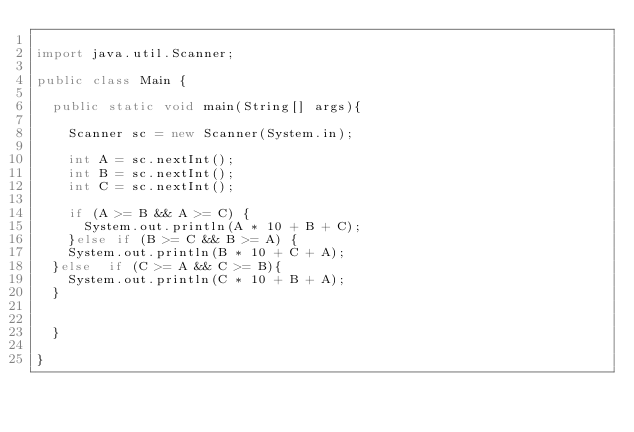<code> <loc_0><loc_0><loc_500><loc_500><_Java_>
import java.util.Scanner;

public class Main {

  public static void main(String[] args){

    Scanner sc = new Scanner(System.in);

    int A = sc.nextInt();
    int B = sc.nextInt();
    int C = sc.nextInt();

    if (A >= B && A >= C) {
      System.out.println(A * 10 + B + C);
    }else if (B >= C && B >= A) {
    System.out.println(B * 10 + C + A);
  }else  if (C >= A && C >= B){
    System.out.println(C * 10 + B + A);
  }


  }

}
</code> 